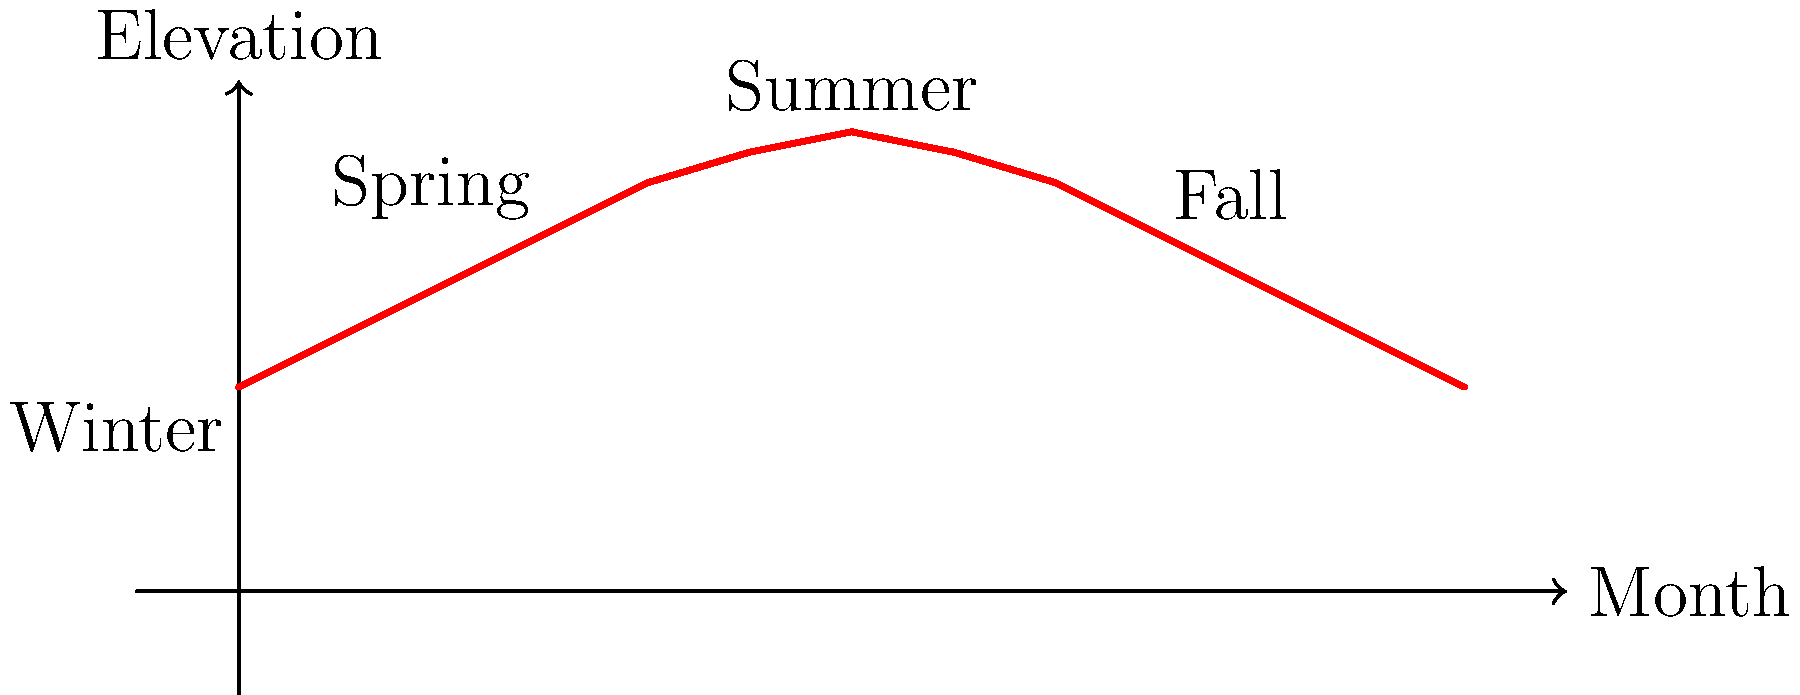As a botanist, you understand the importance of sunlight for plant growth. The graph shows the apparent path of the sun across the sky throughout the year. Why does this pattern occur, and how might it affect your choice of native plant species for different areas of a garden? 1. The graph represents the sun's elevation in the sky throughout the year:
   - The x-axis shows the months (0 = January, 12 = December)
   - The y-axis represents the sun's elevation at solar noon

2. The pattern occurs due to Earth's axial tilt and its orbit around the sun:
   - Earth's axis is tilted at approximately 23.5° relative to its orbital plane
   - This tilt remains constant as Earth orbits the sun

3. Seasonal changes in sun elevation:
   - Summer solstice (around June): Highest sun elevation
   - Winter solstice (around December): Lowest sun elevation
   - Spring and fall equinoxes: Intermediate elevations

4. Impact on plant growth and garden planning:
   - Higher sun elevation in summer = more intense and longer duration of sunlight
   - Lower sun elevation in winter = less intense and shorter duration of sunlight

5. Considerations for plant placement:
   - South-facing areas receive more direct sunlight year-round
   - North-facing areas receive less direct sunlight, especially in winter
   - East and west-facing areas receive morning and afternoon sun, respectively

6. Native plant selection based on sun exposure:
   - Full sun plants (e.g., prairie species) in south-facing areas
   - Shade-tolerant plants (e.g., woodland species) in north-facing areas
   - Plants with intermediate light requirements in east or west-facing areas

7. Seasonal adaptations:
   - Deciduous trees provide shade in summer but allow light through in winter
   - Evergreen plants can provide year-round screening or windbreaks

Understanding this solar pattern helps in selecting and placing native plants to optimize their growth and create a successful, sustainable garden ecosystem.
Answer: Earth's axial tilt causes seasonal changes in sun elevation, affecting light intensity and duration. This influences plant placement and species selection in gardens based on sun exposure requirements. 